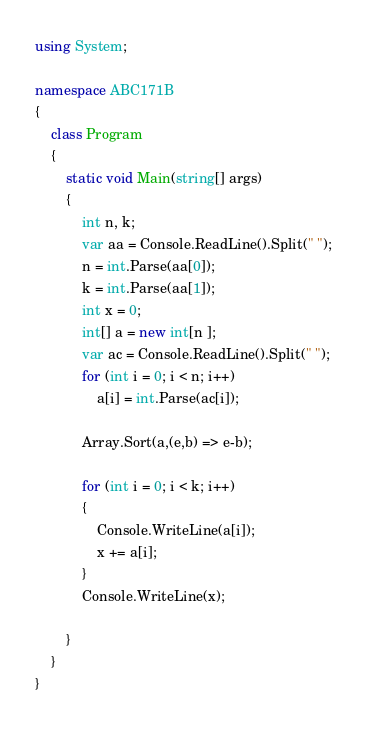<code> <loc_0><loc_0><loc_500><loc_500><_C#_>using System;

namespace ABC171B
{
    class Program
    {
        static void Main(string[] args)
        {
            int n, k;
            var aa = Console.ReadLine().Split(" ");
            n = int.Parse(aa[0]);
            k = int.Parse(aa[1]);
            int x = 0;
            int[] a = new int[n ];
            var ac = Console.ReadLine().Split(" ");
            for (int i = 0; i < n; i++)
                a[i] = int.Parse(ac[i]);

            Array.Sort(a,(e,b) => e-b);

            for (int i = 0; i < k; i++)
            {
                Console.WriteLine(a[i]);
                x += a[i];
            }
            Console.WriteLine(x);

        }
    }
}
</code> 